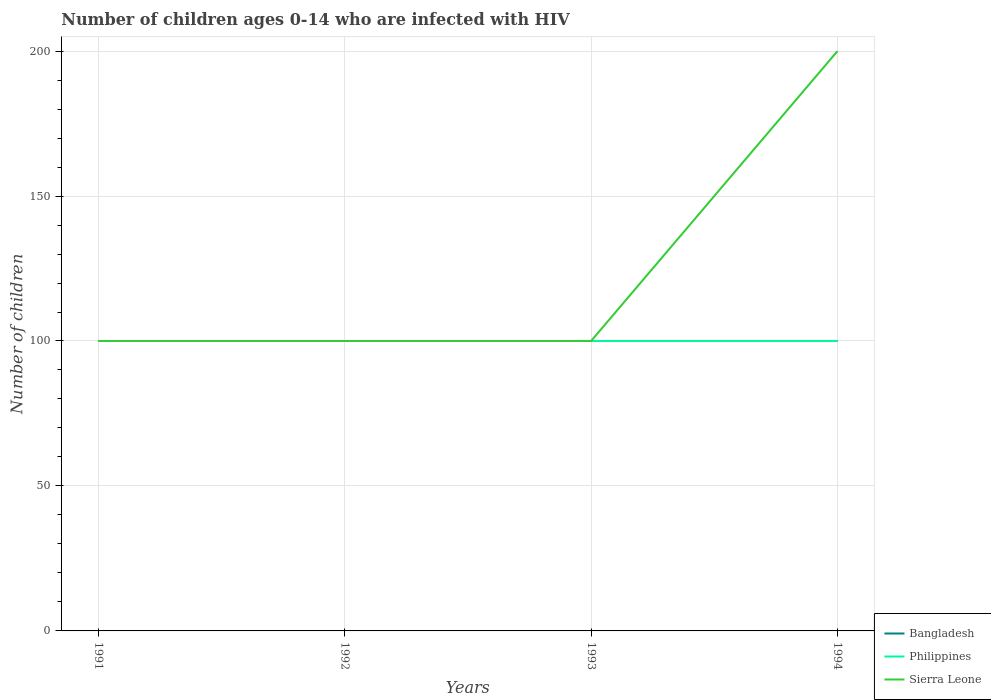Is the number of lines equal to the number of legend labels?
Your response must be concise. Yes. Across all years, what is the maximum number of HIV infected children in Philippines?
Give a very brief answer. 100. In which year was the number of HIV infected children in Philippines maximum?
Offer a terse response. 1991. What is the difference between the highest and the second highest number of HIV infected children in Sierra Leone?
Provide a succinct answer. 100. What is the difference between the highest and the lowest number of HIV infected children in Philippines?
Make the answer very short. 0. Is the number of HIV infected children in Sierra Leone strictly greater than the number of HIV infected children in Philippines over the years?
Provide a short and direct response. No. How many lines are there?
Offer a very short reply. 3. How many years are there in the graph?
Ensure brevity in your answer.  4. Are the values on the major ticks of Y-axis written in scientific E-notation?
Ensure brevity in your answer.  No. Does the graph contain any zero values?
Give a very brief answer. No. How many legend labels are there?
Give a very brief answer. 3. What is the title of the graph?
Provide a short and direct response. Number of children ages 0-14 who are infected with HIV. Does "Guyana" appear as one of the legend labels in the graph?
Offer a terse response. No. What is the label or title of the Y-axis?
Provide a short and direct response. Number of children. What is the Number of children in Philippines in 1991?
Make the answer very short. 100. What is the Number of children of Sierra Leone in 1991?
Ensure brevity in your answer.  100. What is the Number of children of Philippines in 1992?
Your answer should be compact. 100. What is the Number of children in Sierra Leone in 1992?
Make the answer very short. 100. What is the Number of children of Bangladesh in 1993?
Ensure brevity in your answer.  100. What is the Number of children in Philippines in 1993?
Your answer should be compact. 100. Across all years, what is the minimum Number of children of Sierra Leone?
Your response must be concise. 100. What is the total Number of children of Sierra Leone in the graph?
Ensure brevity in your answer.  500. What is the difference between the Number of children of Sierra Leone in 1991 and that in 1992?
Offer a very short reply. 0. What is the difference between the Number of children in Bangladesh in 1991 and that in 1993?
Provide a short and direct response. 0. What is the difference between the Number of children of Bangladesh in 1991 and that in 1994?
Your answer should be very brief. 0. What is the difference between the Number of children in Philippines in 1991 and that in 1994?
Ensure brevity in your answer.  0. What is the difference between the Number of children in Sierra Leone in 1991 and that in 1994?
Offer a very short reply. -100. What is the difference between the Number of children in Bangladesh in 1992 and that in 1993?
Offer a terse response. 0. What is the difference between the Number of children of Philippines in 1992 and that in 1993?
Provide a short and direct response. 0. What is the difference between the Number of children of Philippines in 1992 and that in 1994?
Your answer should be compact. 0. What is the difference between the Number of children in Sierra Leone in 1992 and that in 1994?
Ensure brevity in your answer.  -100. What is the difference between the Number of children of Bangladesh in 1993 and that in 1994?
Your answer should be very brief. 0. What is the difference between the Number of children of Philippines in 1993 and that in 1994?
Ensure brevity in your answer.  0. What is the difference between the Number of children in Sierra Leone in 1993 and that in 1994?
Ensure brevity in your answer.  -100. What is the difference between the Number of children of Philippines in 1991 and the Number of children of Sierra Leone in 1992?
Keep it short and to the point. 0. What is the difference between the Number of children in Bangladesh in 1991 and the Number of children in Philippines in 1994?
Your answer should be compact. 0. What is the difference between the Number of children of Bangladesh in 1991 and the Number of children of Sierra Leone in 1994?
Offer a very short reply. -100. What is the difference between the Number of children of Philippines in 1991 and the Number of children of Sierra Leone in 1994?
Offer a terse response. -100. What is the difference between the Number of children of Bangladesh in 1992 and the Number of children of Philippines in 1993?
Offer a terse response. 0. What is the difference between the Number of children of Bangladesh in 1992 and the Number of children of Sierra Leone in 1993?
Give a very brief answer. 0. What is the difference between the Number of children in Bangladesh in 1992 and the Number of children in Philippines in 1994?
Your answer should be very brief. 0. What is the difference between the Number of children in Bangladesh in 1992 and the Number of children in Sierra Leone in 1994?
Ensure brevity in your answer.  -100. What is the difference between the Number of children in Philippines in 1992 and the Number of children in Sierra Leone in 1994?
Your answer should be compact. -100. What is the difference between the Number of children in Bangladesh in 1993 and the Number of children in Sierra Leone in 1994?
Provide a succinct answer. -100. What is the difference between the Number of children of Philippines in 1993 and the Number of children of Sierra Leone in 1994?
Provide a short and direct response. -100. What is the average Number of children in Bangladesh per year?
Offer a very short reply. 100. What is the average Number of children in Sierra Leone per year?
Provide a succinct answer. 125. In the year 1991, what is the difference between the Number of children in Philippines and Number of children in Sierra Leone?
Provide a succinct answer. 0. In the year 1992, what is the difference between the Number of children in Bangladesh and Number of children in Sierra Leone?
Offer a very short reply. 0. In the year 1992, what is the difference between the Number of children of Philippines and Number of children of Sierra Leone?
Offer a very short reply. 0. In the year 1993, what is the difference between the Number of children of Bangladesh and Number of children of Sierra Leone?
Provide a succinct answer. 0. In the year 1994, what is the difference between the Number of children in Bangladesh and Number of children in Sierra Leone?
Provide a succinct answer. -100. In the year 1994, what is the difference between the Number of children in Philippines and Number of children in Sierra Leone?
Provide a succinct answer. -100. What is the ratio of the Number of children in Philippines in 1991 to that in 1992?
Provide a succinct answer. 1. What is the ratio of the Number of children in Philippines in 1991 to that in 1993?
Provide a short and direct response. 1. What is the ratio of the Number of children in Sierra Leone in 1991 to that in 1994?
Provide a succinct answer. 0.5. What is the ratio of the Number of children of Bangladesh in 1992 to that in 1993?
Provide a short and direct response. 1. What is the ratio of the Number of children of Sierra Leone in 1992 to that in 1993?
Provide a short and direct response. 1. What is the ratio of the Number of children of Bangladesh in 1992 to that in 1994?
Offer a terse response. 1. What is the ratio of the Number of children in Bangladesh in 1993 to that in 1994?
Your answer should be very brief. 1. What is the ratio of the Number of children of Philippines in 1993 to that in 1994?
Keep it short and to the point. 1. What is the ratio of the Number of children of Sierra Leone in 1993 to that in 1994?
Give a very brief answer. 0.5. What is the difference between the highest and the second highest Number of children of Bangladesh?
Provide a succinct answer. 0. What is the difference between the highest and the second highest Number of children of Philippines?
Offer a very short reply. 0. What is the difference between the highest and the second highest Number of children of Sierra Leone?
Your answer should be compact. 100. What is the difference between the highest and the lowest Number of children in Philippines?
Your answer should be compact. 0. 